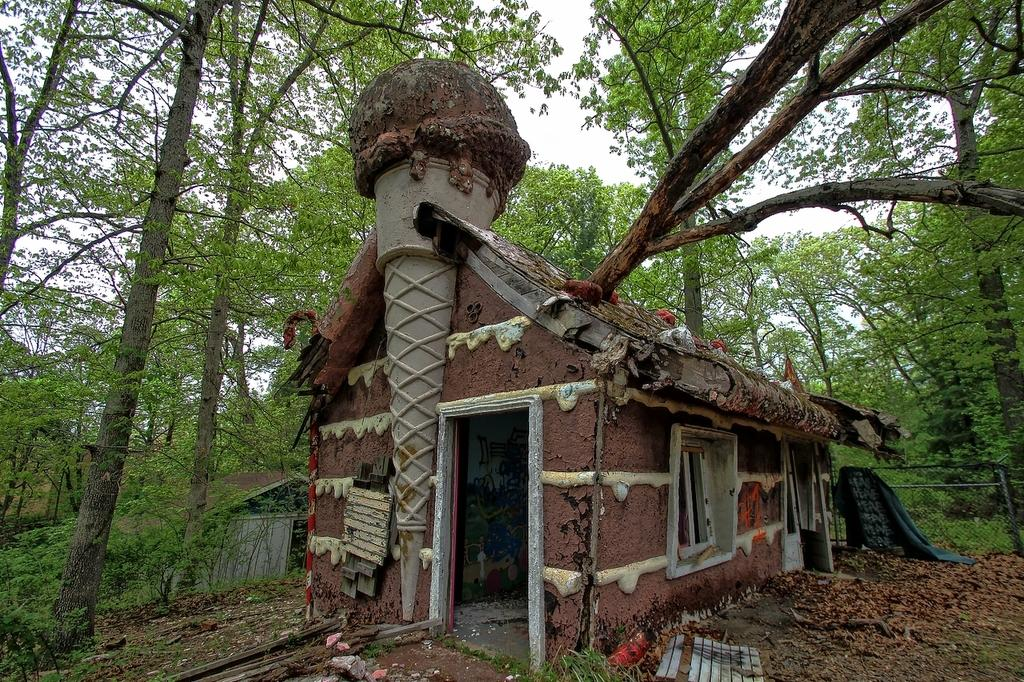What type of structures can be seen in the image? There are sheds in the image. What type of vegetation debris can be seen on the ground? Dried leaves are present in the image. What is on the ground in the image? There are objects on the ground in the image. What type of barrier can be seen in the image? There is a fence in the image. What type of natural elements can be seen in the image? Trees are visible in the image. What is visible in the background of the image? The sky is visible in the background of the image. What type of cork can be seen floating in the image? There is no cork present in the image. What type of key is used to unlock the sheds in the image? The image does not show any keys or locks on the sheds, so it cannot be determined which key might be used. 